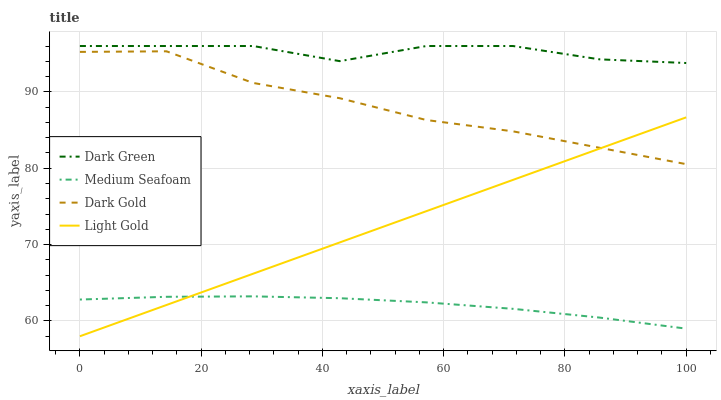Does Medium Seafoam have the minimum area under the curve?
Answer yes or no. Yes. Does Dark Green have the maximum area under the curve?
Answer yes or no. Yes. Does Light Gold have the minimum area under the curve?
Answer yes or no. No. Does Light Gold have the maximum area under the curve?
Answer yes or no. No. Is Light Gold the smoothest?
Answer yes or no. Yes. Is Dark Green the roughest?
Answer yes or no. Yes. Is Medium Seafoam the smoothest?
Answer yes or no. No. Is Medium Seafoam the roughest?
Answer yes or no. No. Does Medium Seafoam have the lowest value?
Answer yes or no. No. Does Light Gold have the highest value?
Answer yes or no. No. Is Light Gold less than Dark Green?
Answer yes or no. Yes. Is Dark Green greater than Dark Gold?
Answer yes or no. Yes. Does Light Gold intersect Dark Green?
Answer yes or no. No. 